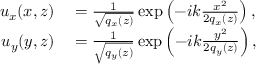Convert formula to latex. <formula><loc_0><loc_0><loc_500><loc_500>\begin{array} { r l } { u _ { x } ( x , z ) } & = { \frac { 1 } { \sqrt { { q } _ { x } ( z ) } } } \exp \left ( - i k { \frac { x ^ { 2 } } { 2 { q } _ { x } ( z ) } } \right ) , } \\ { u _ { y } ( y , z ) } & = { \frac { 1 } { \sqrt { { q } _ { y } ( z ) } } } \exp \left ( - i k { \frac { y ^ { 2 } } { 2 { q } _ { y } ( z ) } } \right ) , } \end{array}</formula> 